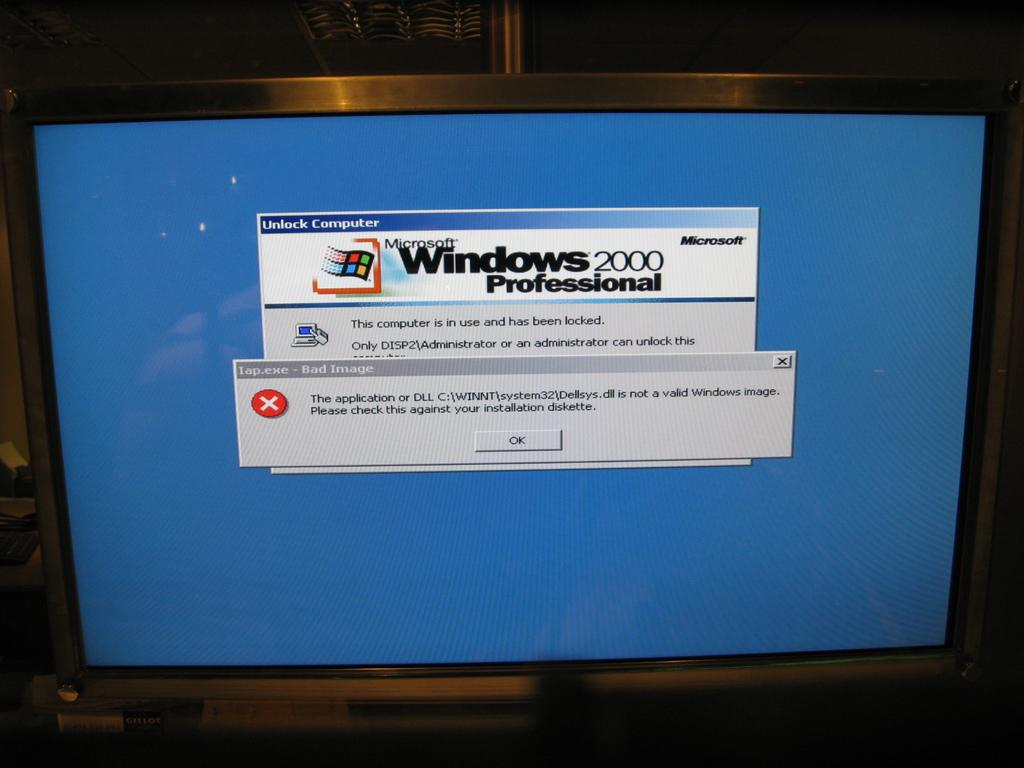<image>
Describe the image concisely. a pc screen on the blue screen of death with the warning pop up that the application is not a valid image 